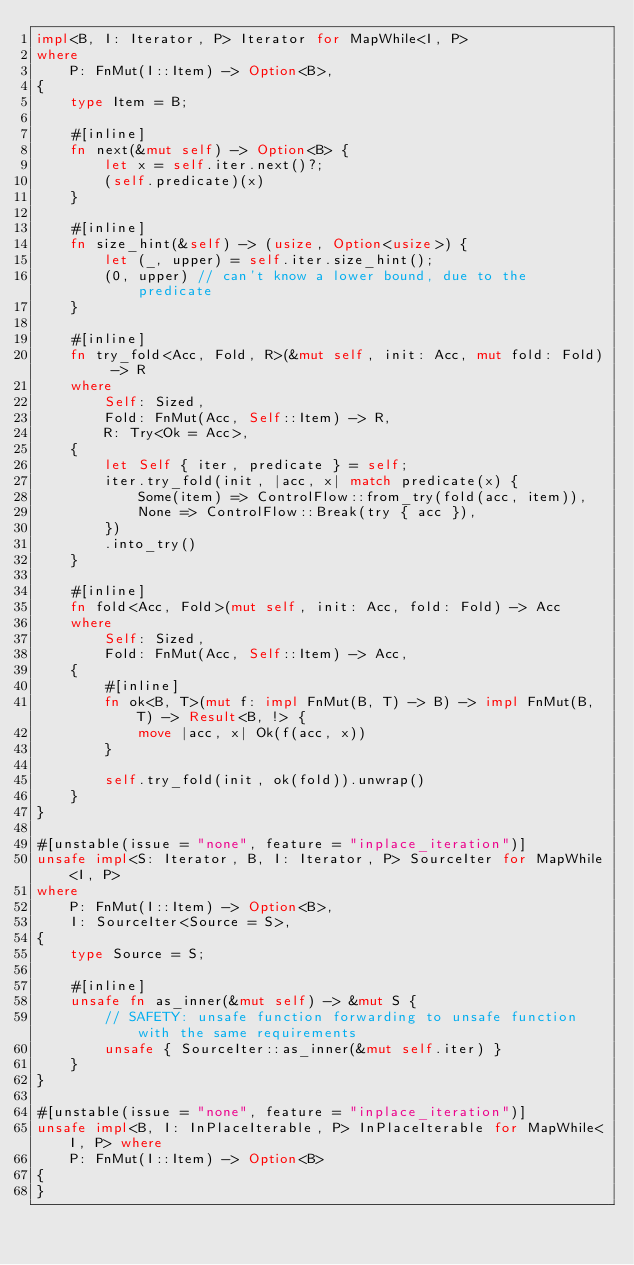Convert code to text. <code><loc_0><loc_0><loc_500><loc_500><_Rust_>impl<B, I: Iterator, P> Iterator for MapWhile<I, P>
where
    P: FnMut(I::Item) -> Option<B>,
{
    type Item = B;

    #[inline]
    fn next(&mut self) -> Option<B> {
        let x = self.iter.next()?;
        (self.predicate)(x)
    }

    #[inline]
    fn size_hint(&self) -> (usize, Option<usize>) {
        let (_, upper) = self.iter.size_hint();
        (0, upper) // can't know a lower bound, due to the predicate
    }

    #[inline]
    fn try_fold<Acc, Fold, R>(&mut self, init: Acc, mut fold: Fold) -> R
    where
        Self: Sized,
        Fold: FnMut(Acc, Self::Item) -> R,
        R: Try<Ok = Acc>,
    {
        let Self { iter, predicate } = self;
        iter.try_fold(init, |acc, x| match predicate(x) {
            Some(item) => ControlFlow::from_try(fold(acc, item)),
            None => ControlFlow::Break(try { acc }),
        })
        .into_try()
    }

    #[inline]
    fn fold<Acc, Fold>(mut self, init: Acc, fold: Fold) -> Acc
    where
        Self: Sized,
        Fold: FnMut(Acc, Self::Item) -> Acc,
    {
        #[inline]
        fn ok<B, T>(mut f: impl FnMut(B, T) -> B) -> impl FnMut(B, T) -> Result<B, !> {
            move |acc, x| Ok(f(acc, x))
        }

        self.try_fold(init, ok(fold)).unwrap()
    }
}

#[unstable(issue = "none", feature = "inplace_iteration")]
unsafe impl<S: Iterator, B, I: Iterator, P> SourceIter for MapWhile<I, P>
where
    P: FnMut(I::Item) -> Option<B>,
    I: SourceIter<Source = S>,
{
    type Source = S;

    #[inline]
    unsafe fn as_inner(&mut self) -> &mut S {
        // SAFETY: unsafe function forwarding to unsafe function with the same requirements
        unsafe { SourceIter::as_inner(&mut self.iter) }
    }
}

#[unstable(issue = "none", feature = "inplace_iteration")]
unsafe impl<B, I: InPlaceIterable, P> InPlaceIterable for MapWhile<I, P> where
    P: FnMut(I::Item) -> Option<B>
{
}
</code> 